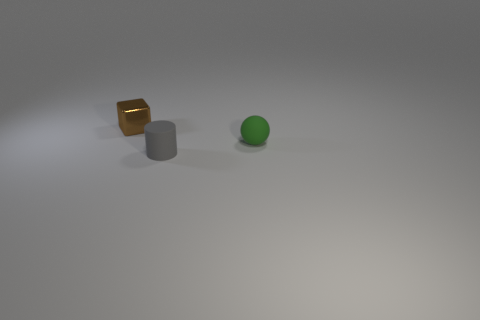Add 3 big metallic objects. How many objects exist? 6 Subtract all cylinders. How many objects are left? 2 Add 1 tiny gray rubber things. How many tiny gray rubber things are left? 2 Add 3 gray objects. How many gray objects exist? 4 Subtract 0 blue cylinders. How many objects are left? 3 Subtract all green blocks. Subtract all cyan spheres. How many blocks are left? 1 Subtract all shiny things. Subtract all blue matte cylinders. How many objects are left? 2 